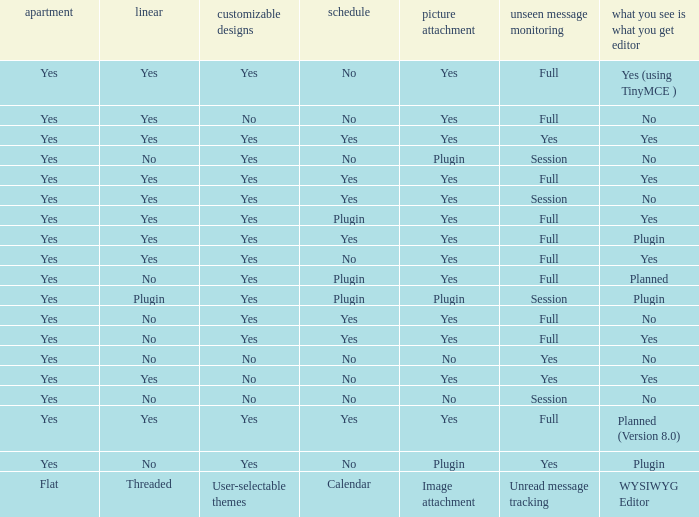Which Calendar has a User-selectable themes of user-selectable themes? Calendar. 